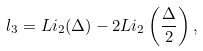<formula> <loc_0><loc_0><loc_500><loc_500>l _ { 3 } = L i _ { 2 } ( \Delta ) - 2 L i _ { 2 } \left ( \frac { \Delta } { 2 } \right ) ,</formula> 